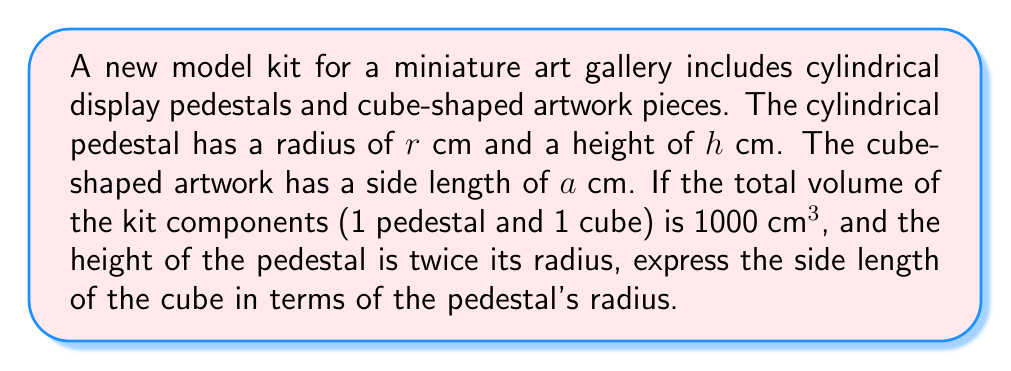Solve this math problem. Let's approach this step-by-step:

1) First, let's define our variables:
   $r$ = radius of the cylindrical pedestal
   $h$ = height of the cylindrical pedestal
   $a$ = side length of the cube

2) We're given that the height of the pedestal is twice its radius:
   $h = 2r$

3) The volume of a cylinder is given by $V_{cylinder} = \pi r^2 h$
   Substituting $h = 2r$:
   $V_{cylinder} = \pi r^2 (2r) = 2\pi r^3$

4) The volume of a cube is given by $V_{cube} = a^3$

5) We're told that the total volume is 1000 cm³:
   $V_{total} = V_{cylinder} + V_{cube} = 1000$
   $2\pi r^3 + a^3 = 1000$

6) We need to express $a$ in terms of $r$:
   $a^3 = 1000 - 2\pi r^3$
   $a = \sqrt[3]{1000 - 2\pi r^3}$

This gives us the side length of the cube in terms of the pedestal's radius.
Answer: $a = \sqrt[3]{1000 - 2\pi r^3}$ 